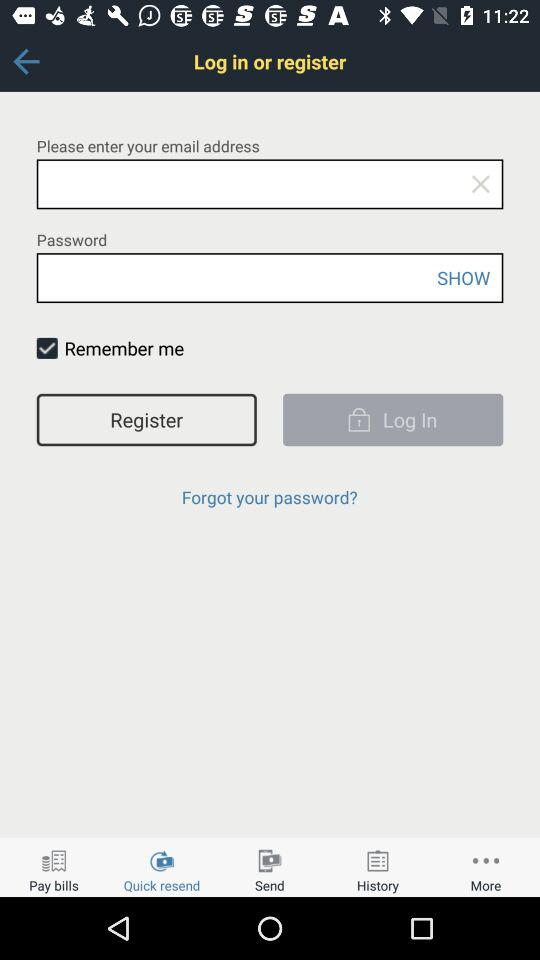Which tab am I on? You are on "Quick resend" tab. 